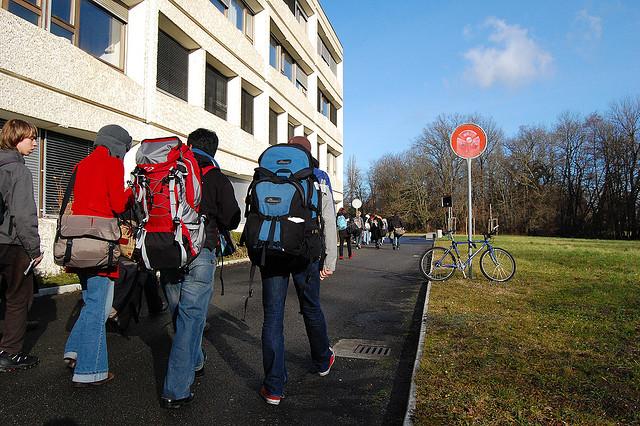Where is the bike?
Write a very short answer. Grass. Is that a stop sign?
Keep it brief. No. What color is the right backpack?
Write a very short answer. Blue. 